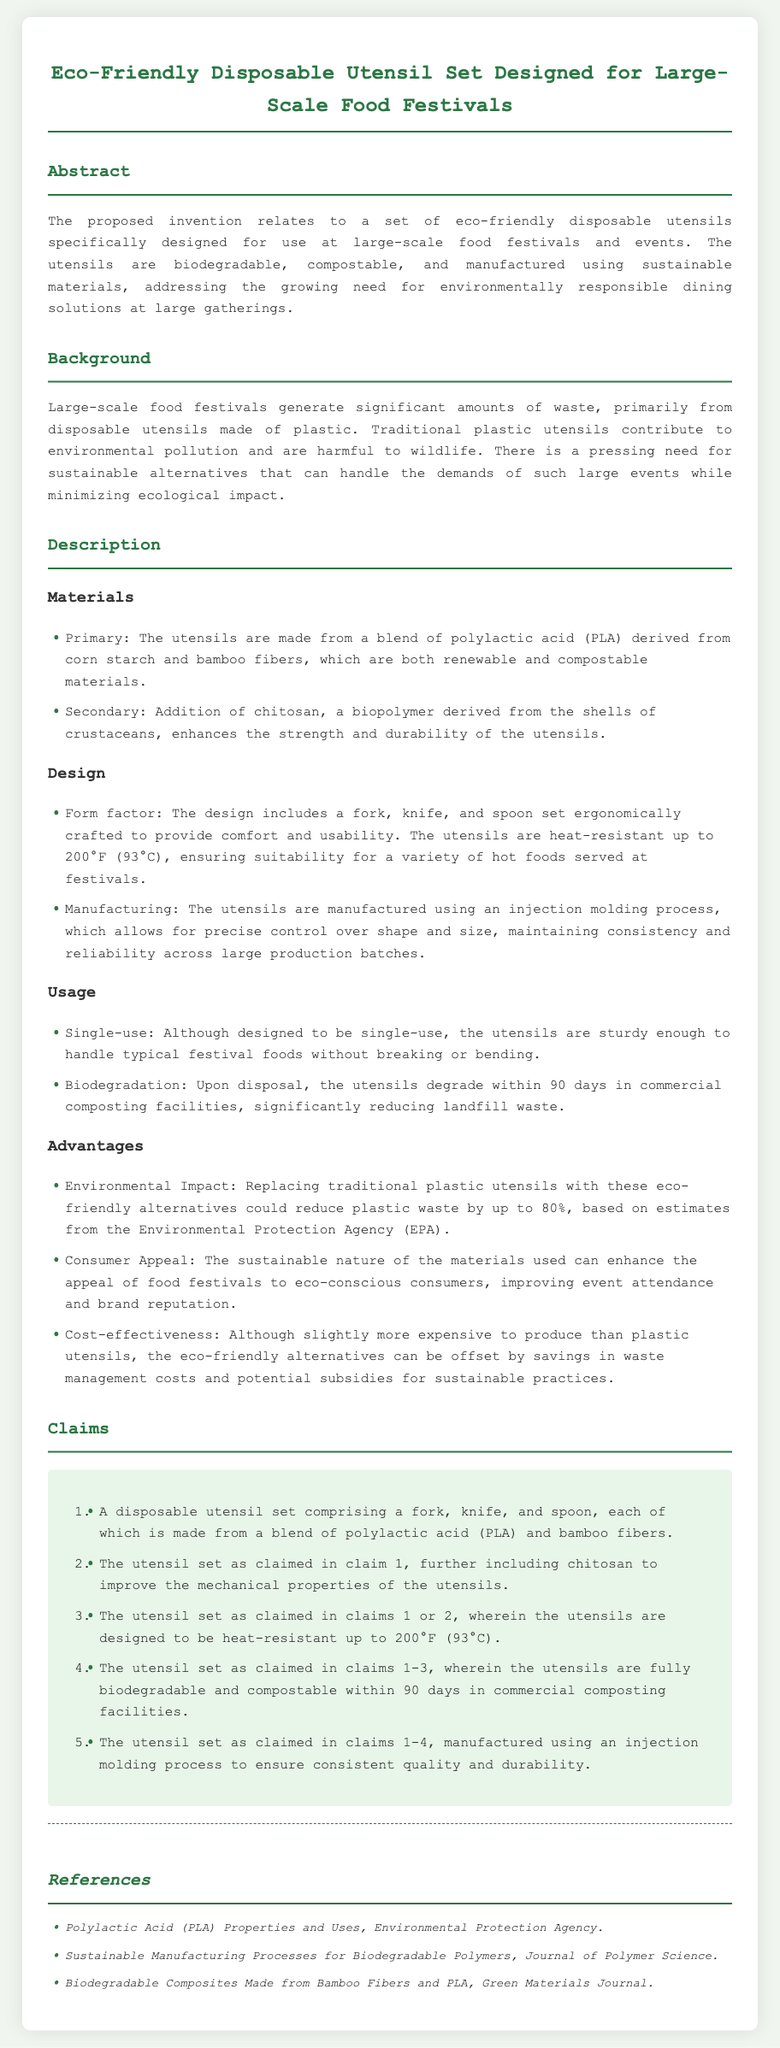What materials are used for the utensils? The utensils are made from a blend of polylactic acid (PLA) derived from corn starch and bamboo fibers, and chitosan is included to enhance strength.
Answer: PLA and bamboo fibers What is the heat resistance of the utensils? The utensils are designed to be heat-resistant up to 200°F (93°C), ensuring they can handle hot foods.
Answer: 200°F (93°C) How long do the utensils take to biodegrade? Upon disposal, the utensils degrade within 90 days in commercial composting facilities, significantly reducing waste.
Answer: 90 days What is the potential reduction in plastic waste? Replacing traditional plastic utensils with these alternatives could reduce plastic waste by up to 80%.
Answer: 80% What is the primary function of the invention? The invention addresses the need for environmentally responsible dining solutions at large gatherings like food festivals.
Answer: Environmentally responsible dining solutions How are the utensils manufactured? The utensils are manufactured using an injection molding process, allowing precise control over shape and size.
Answer: Injection molding process What are the advantages of the utensil set? Advantages include environmental impact, consumer appeal, and cost-effectiveness in waste management.
Answer: Environmental impact, consumer appeal, cost-effectiveness What type of document is this? This document is a patent application detailing a specific invention related to disposable utensils.
Answer: Patent application 